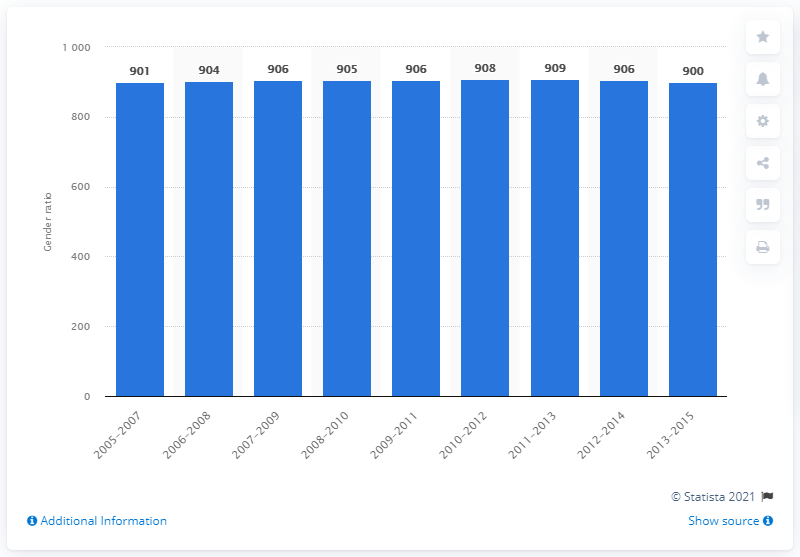Highlight a few significant elements in this photo. Out of every 1,000 males present, 900 were females. The gender ratio in India between 2013 and 2015 was approximately 900. 